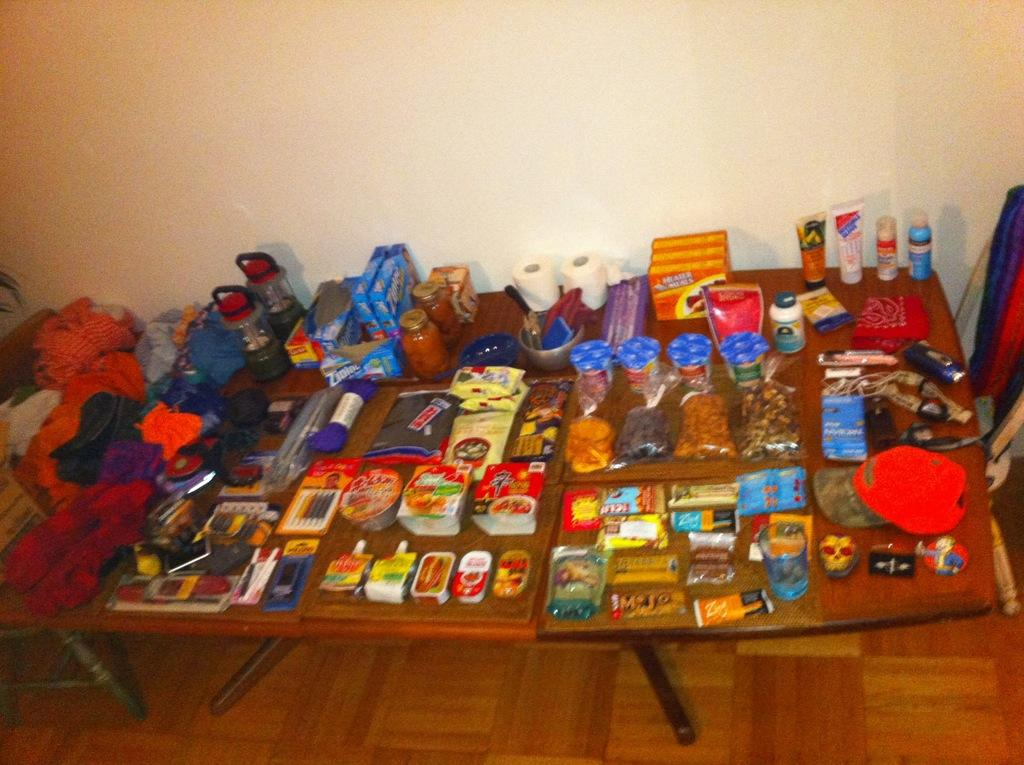What is present on the table in the image? There are food items on a table. Where is the hall located in the image? There is no mention of a hall in the image; it only features food items on a table. 